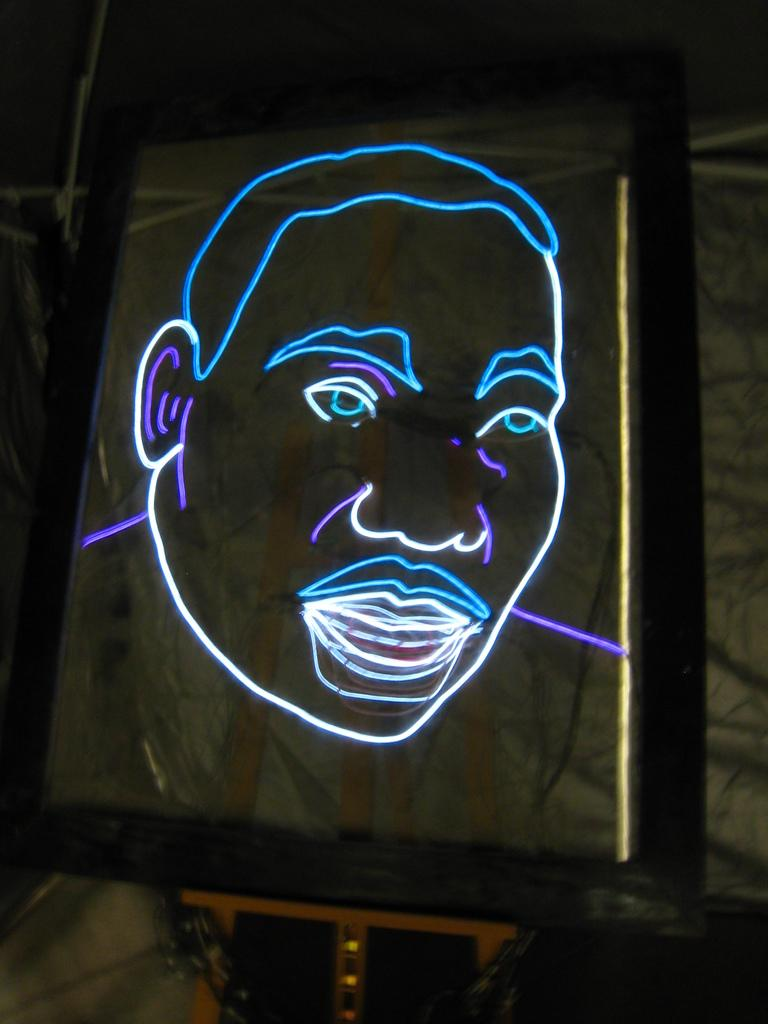What is the main subject of the image? The main subject of the image is a neon sign of a man's face. What is the neon sign attached to? The neon sign is on a glass object. Where is the glass object placed? The glass object is on a drawing stand. What can be seen in the background of the image? There are objects visible in the background of the image. How many knots are tied in the sand in the image? There are no knots or sand present in the image; it features a neon sign of a man's face on a glass object placed on a drawing stand. What type of creature is seen playing with a pail in the image? There is no creature or pail present in the image. 